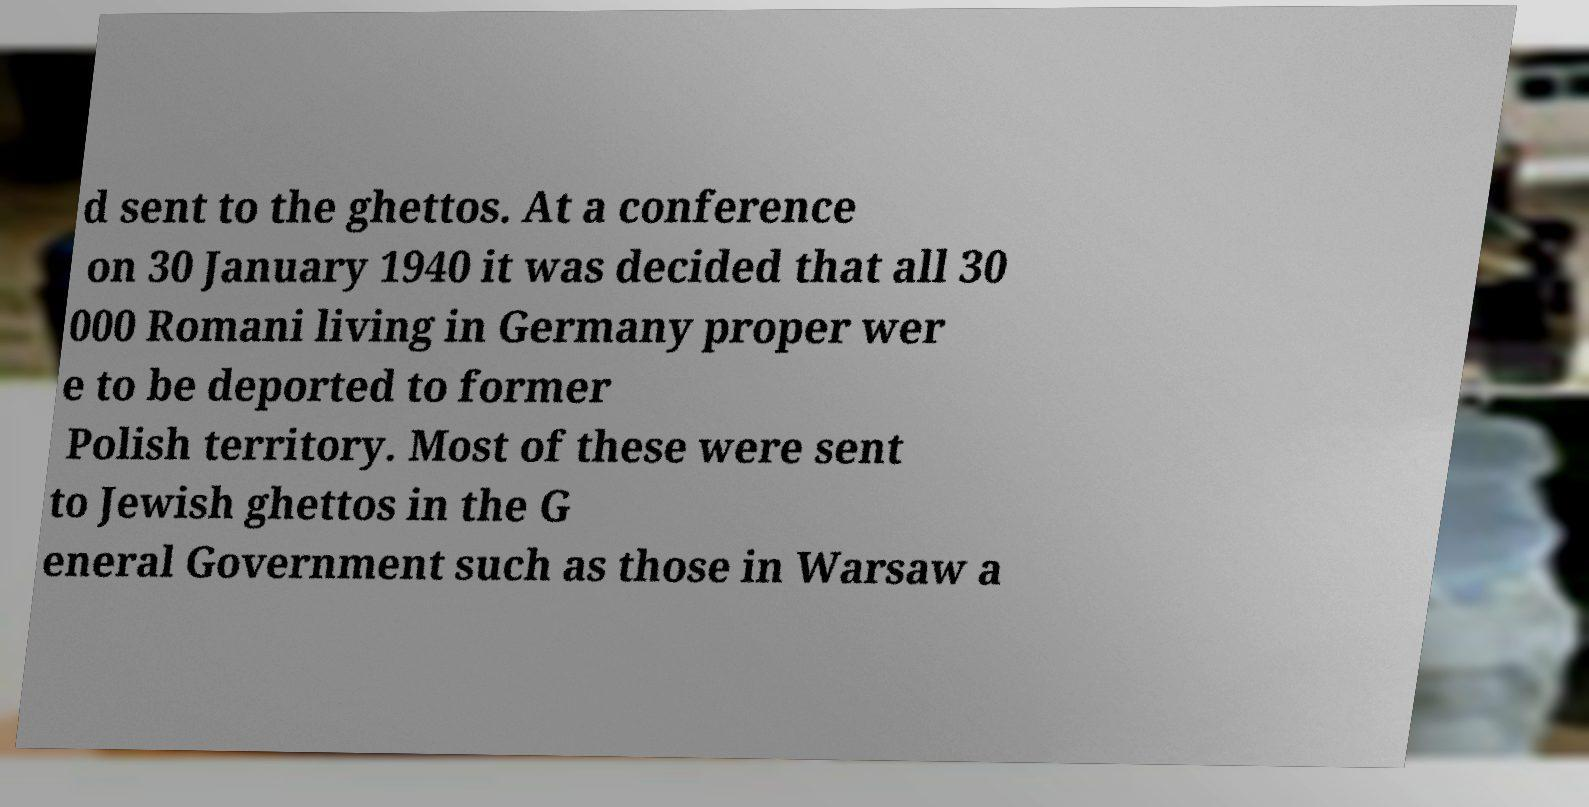Can you read and provide the text displayed in the image?This photo seems to have some interesting text. Can you extract and type it out for me? d sent to the ghettos. At a conference on 30 January 1940 it was decided that all 30 000 Romani living in Germany proper wer e to be deported to former Polish territory. Most of these were sent to Jewish ghettos in the G eneral Government such as those in Warsaw a 